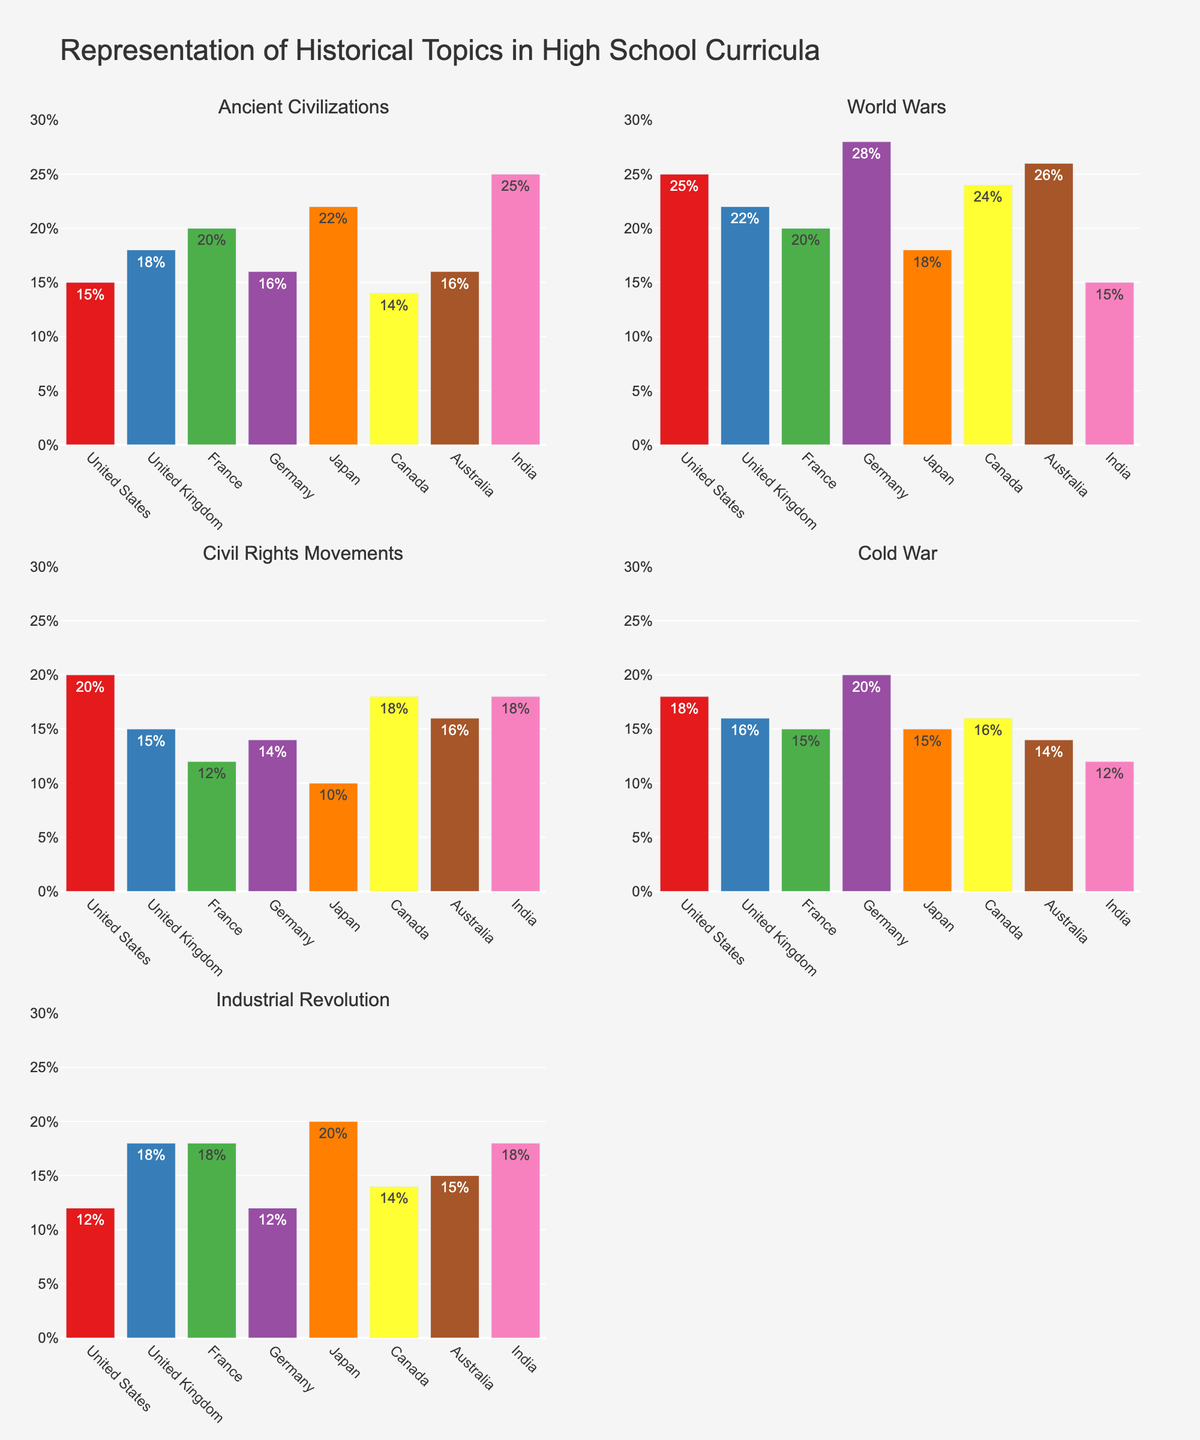What is the overall title of the figure? The title is found at the top of the figure and gives an overview of the subject being represented.
Answer: "Representation of Historical Topics in High School Curricula" Which country has the highest representation for "Ancient Civilizations"? By looking at the bar for "Ancient Civilizations" in the corresponding subplot, the tallest bar belongs to India.
Answer: India How does the percentage representation of "World Wars" differ between the United States and Germany? In the "World Wars" subplot, the bar for Germany is at 28% and the bar for the United States is at 25%. The difference is calculated as 28% - 25%.
Answer: 3% What is the average representation of the "Cold War" topic across all countries? Sum up all the percentages for the "Cold War" topic and divide by the number of countries. The total sum is 18 + 16 + 15 + 20 + 15 + 16 + 14 + 12 = 126. The number of countries is 8, so the average is 126/8.
Answer: 15.75% Which countries have more than 20% representation of "Industrial Revolution"? By scanning the "Industrial Revolution" subplot, the bars that exceed the 20% level belong to Japan and United Kingdom.
Answer: Japan and United Kingdom What is the difference in representation of "Civil Rights Movements" between France and Canada? In the "Civil Rights Movements" subplot, the bar for France is at 12% and the bar for Canada is at 18%. The difference is 18% - 12%.
Answer: 6% Which topic has the highest representation in Japan's high school curriculum? By examining the bars for Japan across all subplots, the tallest bar is for "Ancient Civilizations" at 22%.
Answer: "Ancient Civilizations" Compare the representation of "World Wars" and "Industrial Revolution" in Australia. Which is higher? In the respective subplots, the bar for "World Wars" is at 26% and the bar for "Industrial Revolution" is at 15%. 26% is greater than 15%.
Answer: "World Wars" Between the United States and Canada, which country places more emphasis on the "Civil Rights Movements" topic? In the "Civil Rights Movements" subplot, the bar for the United States is at 20% and for Canada, it is at 18%. 20% is greater than 18%.
Answer: United States 